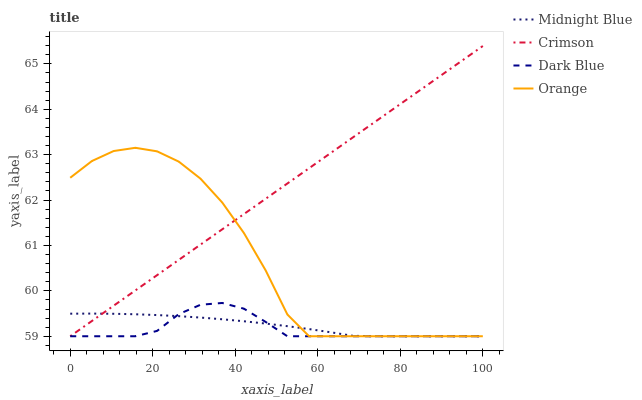Does Dark Blue have the minimum area under the curve?
Answer yes or no. Yes. Does Crimson have the maximum area under the curve?
Answer yes or no. Yes. Does Orange have the minimum area under the curve?
Answer yes or no. No. Does Orange have the maximum area under the curve?
Answer yes or no. No. Is Crimson the smoothest?
Answer yes or no. Yes. Is Orange the roughest?
Answer yes or no. Yes. Is Dark Blue the smoothest?
Answer yes or no. No. Is Dark Blue the roughest?
Answer yes or no. No. Does Crimson have the lowest value?
Answer yes or no. Yes. Does Crimson have the highest value?
Answer yes or no. Yes. Does Dark Blue have the highest value?
Answer yes or no. No. Does Orange intersect Dark Blue?
Answer yes or no. Yes. Is Orange less than Dark Blue?
Answer yes or no. No. Is Orange greater than Dark Blue?
Answer yes or no. No. 